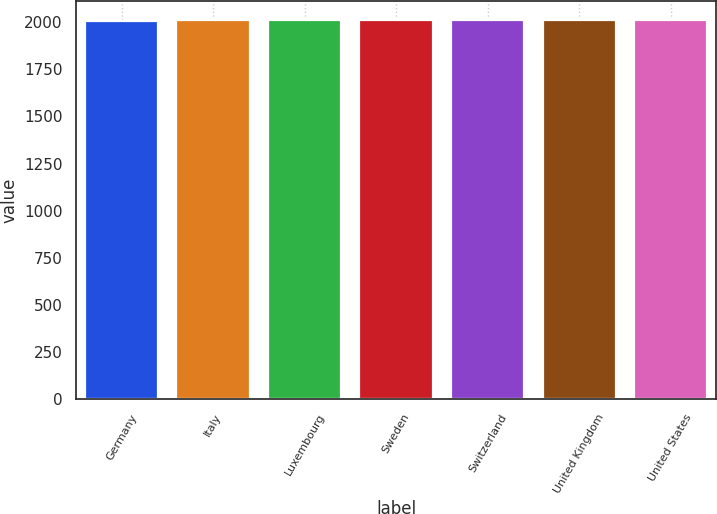<chart> <loc_0><loc_0><loc_500><loc_500><bar_chart><fcel>Germany<fcel>Italy<fcel>Luxembourg<fcel>Sweden<fcel>Switzerland<fcel>United Kingdom<fcel>United States<nl><fcel>2009<fcel>2010<fcel>2011<fcel>2010.3<fcel>2011.3<fcel>2011.6<fcel>2012<nl></chart> 